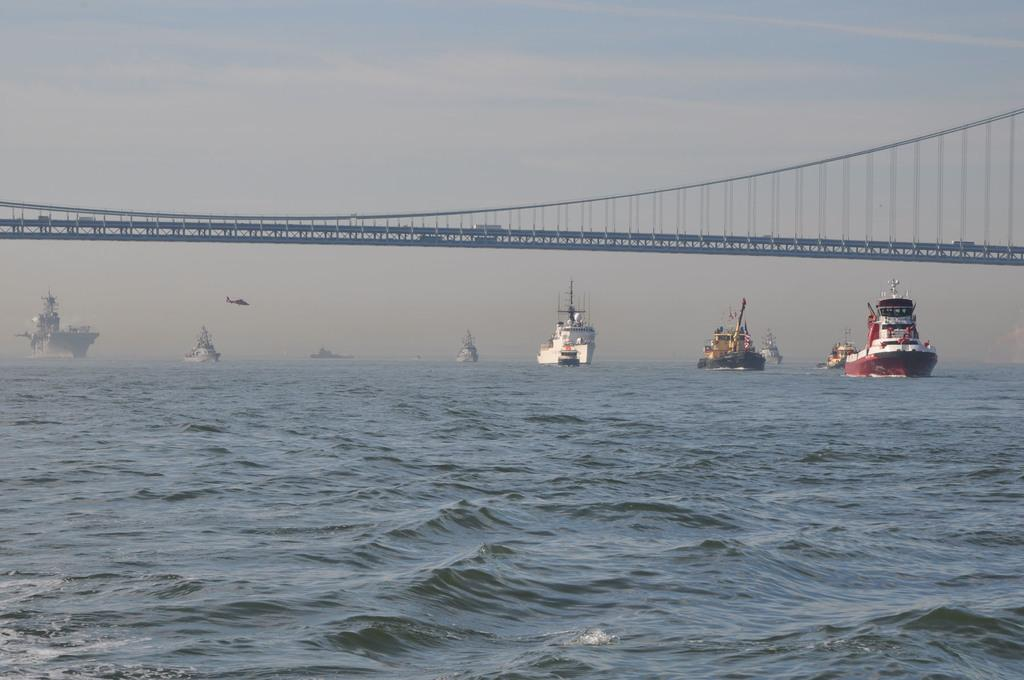What is the main feature of the image? The main feature of the image is water. What structure can be seen in the image? There is a bridge in the image. What else is present on the water in the image? There are ships on the water in the image. What can be seen above the water in the image? The sky is visible in the image. Where is the market located in the image? There is no market present in the image. Who is the representative standing near the water in the image? There is no representative present in the image. 